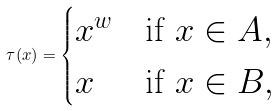Convert formula to latex. <formula><loc_0><loc_0><loc_500><loc_500>\tau ( x ) = \begin{cases} x ^ { w } & \text {if } x \in A , \\ x & \text {if } x \in B , \end{cases}</formula> 